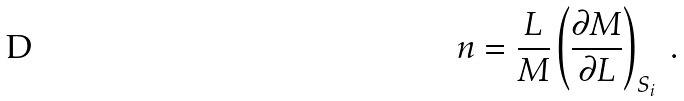<formula> <loc_0><loc_0><loc_500><loc_500>n = \frac { L } { M } \left ( \frac { \partial M } { \partial L } \right ) _ { S _ { i } } \ .</formula> 